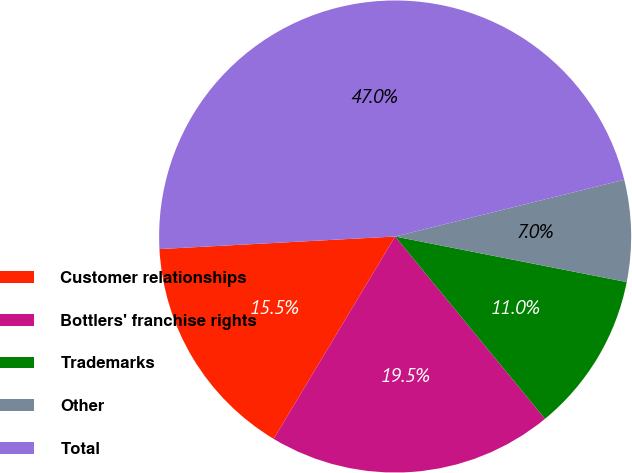<chart> <loc_0><loc_0><loc_500><loc_500><pie_chart><fcel>Customer relationships<fcel>Bottlers' franchise rights<fcel>Trademarks<fcel>Other<fcel>Total<nl><fcel>15.55%<fcel>19.55%<fcel>10.96%<fcel>6.96%<fcel>46.98%<nl></chart> 